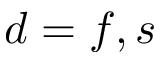Convert formula to latex. <formula><loc_0><loc_0><loc_500><loc_500>d = f , s</formula> 